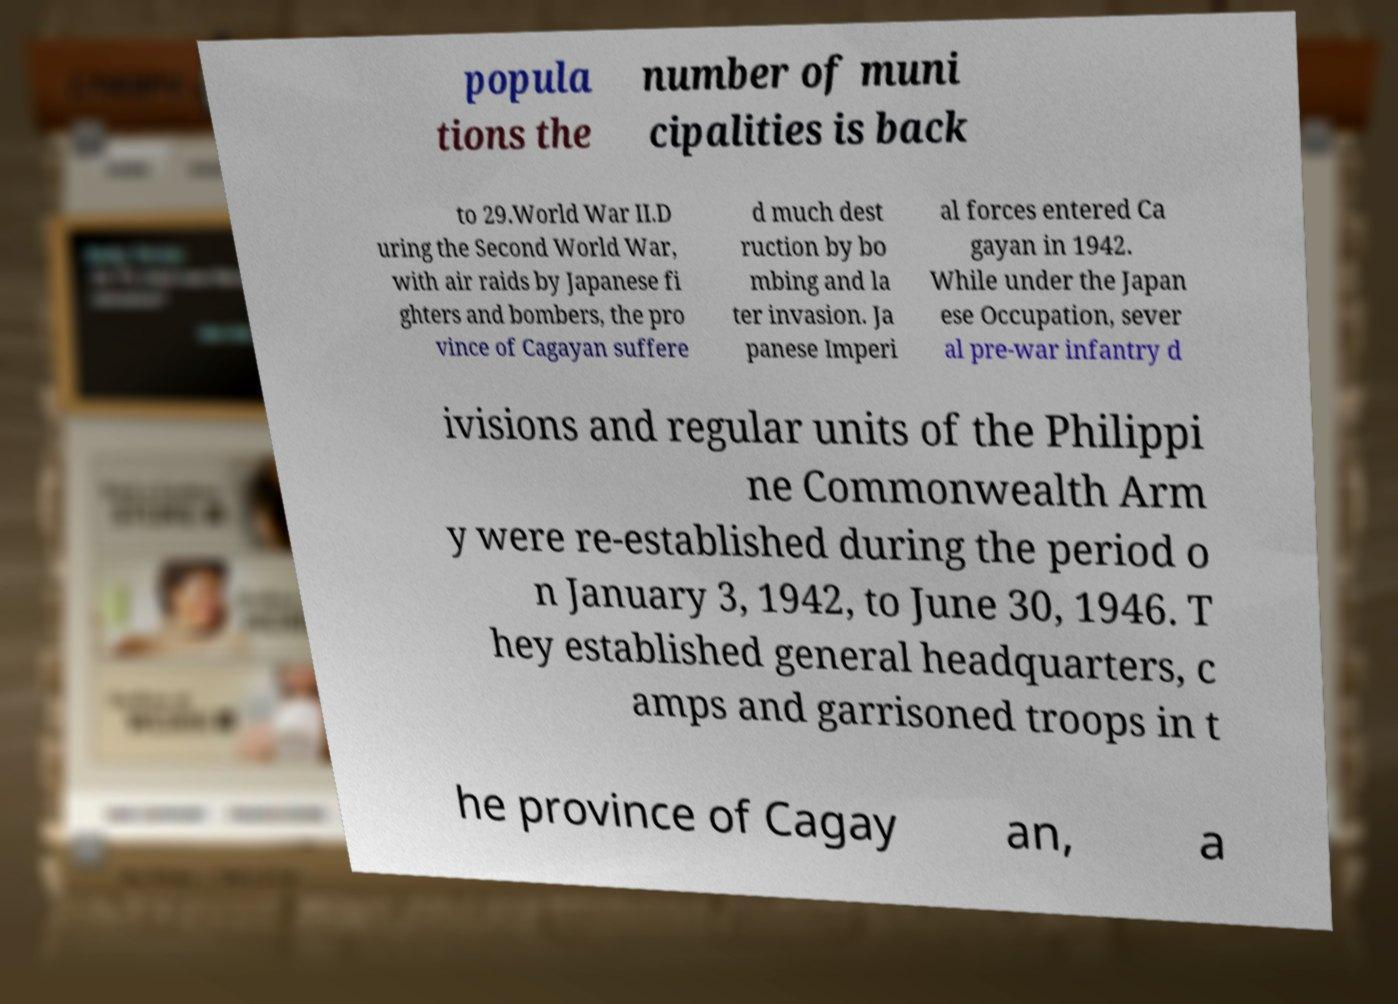There's text embedded in this image that I need extracted. Can you transcribe it verbatim? popula tions the number of muni cipalities is back to 29.World War II.D uring the Second World War, with air raids by Japanese fi ghters and bombers, the pro vince of Cagayan suffere d much dest ruction by bo mbing and la ter invasion. Ja panese Imperi al forces entered Ca gayan in 1942. While under the Japan ese Occupation, sever al pre-war infantry d ivisions and regular units of the Philippi ne Commonwealth Arm y were re-established during the period o n January 3, 1942, to June 30, 1946. T hey established general headquarters, c amps and garrisoned troops in t he province of Cagay an, a 